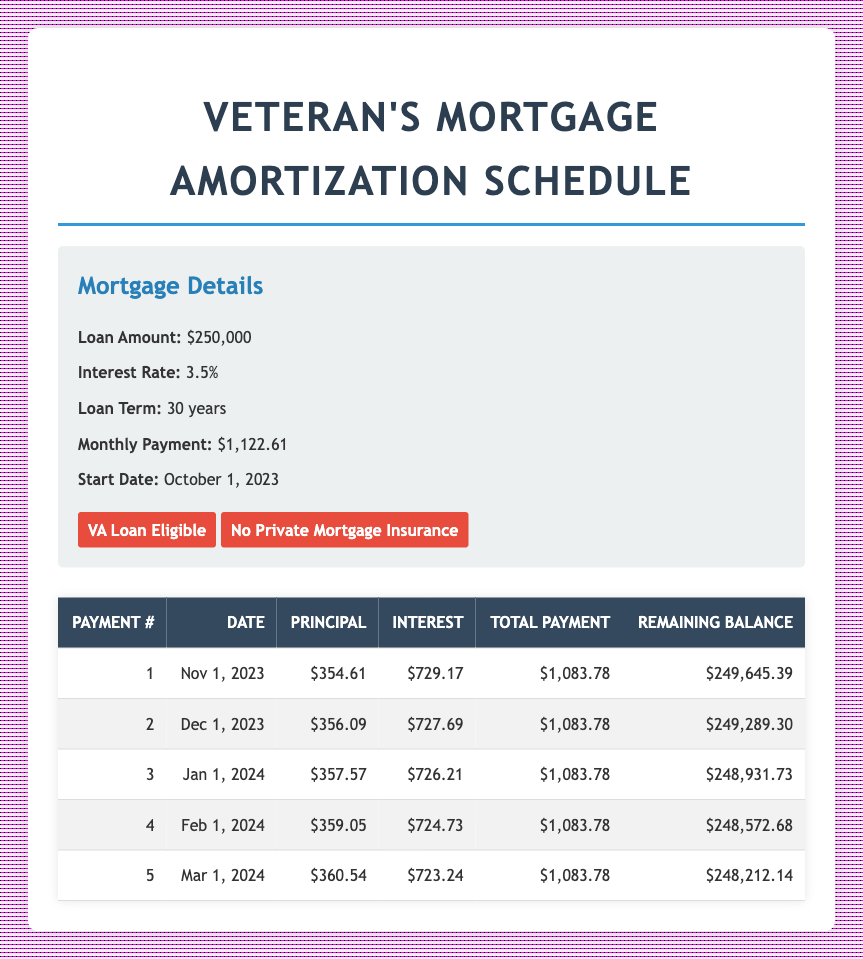What is the total monthly payment for the mortgage? The total monthly payment is listed in the mortgage details section of the table. It is $1,122.61.
Answer: $1,122.61 How much was the principal payment in the first month? The first month's principal payment is directly found in the amortization schedule table under the "Principal" column for payment number 1, which is $354.61.
Answer: $354.61 What was the remaining balance after the second payment? To find the remaining balance after the second payment, refer to the "Remaining Balance" column in the table for payment number 2. The value is $249,289.30.
Answer: $249,289.30 What is the total interest paid in the first three months? The interest payments for the first three months are $729.17, $727.69, and $726.21. Adding these amounts together gives total interest paid: 729.17 + 727.69 + 726.21 = $2,183.07.
Answer: $2,183.07 Is there private mortgage insurance required for this loan? In the mortgage details, it states that there is "No Private Mortgage Insurance." Therefore, the answer is true.
Answer: Yes What is the average principal payment over the first five months? The principal payments for the first five months are $354.61, $356.09, $357.57, $359.05, and $360.54. To find the average, sum these amounts: 354.61 + 356.09 + 357.57 + 359.05 + 360.54 = 1,787.86, then divide by 5, yielding an average principal payment of 1,787.86 / 5 = $357.57.
Answer: $357.57 Which payment has the highest interest payment among the first five? The interest payments for the first five payments are $729.17, $727.69, $726.21, $724.73, and $723.24. Comparing these, the highest interest payment occurs in the first payment ($729.17).
Answer: Payment 1 How much total payment is made after four months? To find the total payment made after four months, add each month's total payment. The payments are $1,083.78 for each of the first four months, so the total payment is 1,083.78 * 4 = $4,335.12.
Answer: $4,335.12 What is the principal payment for payment number 5? Payment number 5's principal payment is directly listed in the amortization schedule table under the "Principal" column for payment number 5, which is $360.54.
Answer: $360.54 